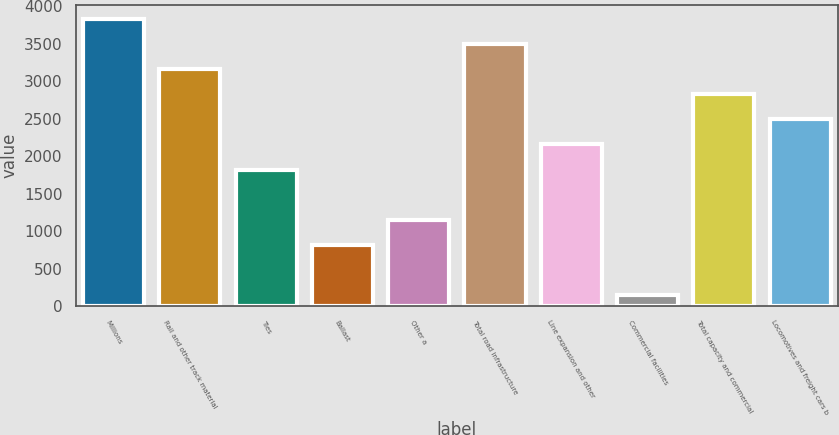<chart> <loc_0><loc_0><loc_500><loc_500><bar_chart><fcel>Millions<fcel>Rail and other track material<fcel>Ties<fcel>Ballast<fcel>Other a<fcel>Total road infrastructure<fcel>Line expansion and other<fcel>Commercial facilities<fcel>Total capacity and commercial<fcel>Locomotives and freight cars b<nl><fcel>3831<fcel>3161<fcel>1821<fcel>816<fcel>1151<fcel>3496<fcel>2156<fcel>146<fcel>2826<fcel>2491<nl></chart> 